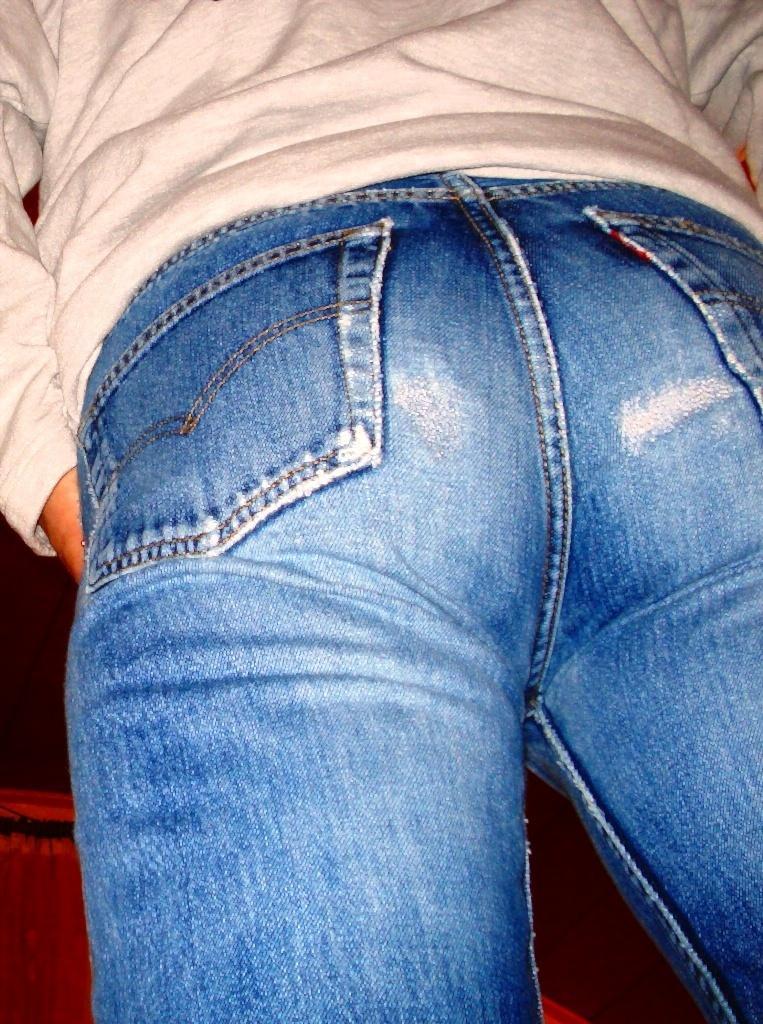Describe this image in one or two sentences. In this picture we can see a person in the t shirt and jeans. 